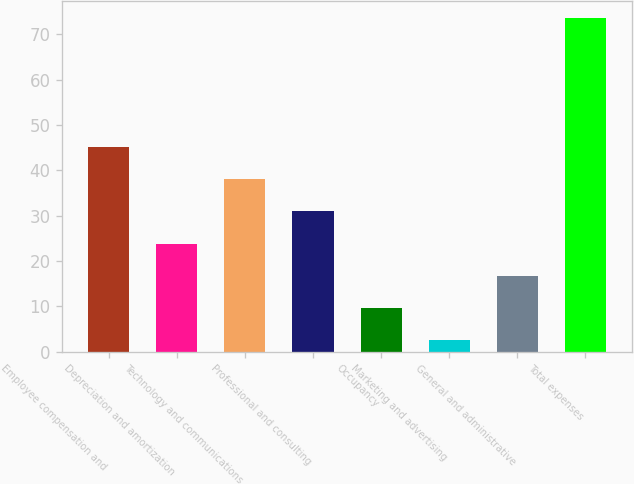Convert chart. <chart><loc_0><loc_0><loc_500><loc_500><bar_chart><fcel>Employee compensation and<fcel>Depreciation and amortization<fcel>Technology and communications<fcel>Professional and consulting<fcel>Occupancy<fcel>Marketing and advertising<fcel>General and administrative<fcel>Total expenses<nl><fcel>45.22<fcel>23.86<fcel>38.1<fcel>30.98<fcel>9.62<fcel>2.5<fcel>16.74<fcel>73.7<nl></chart> 